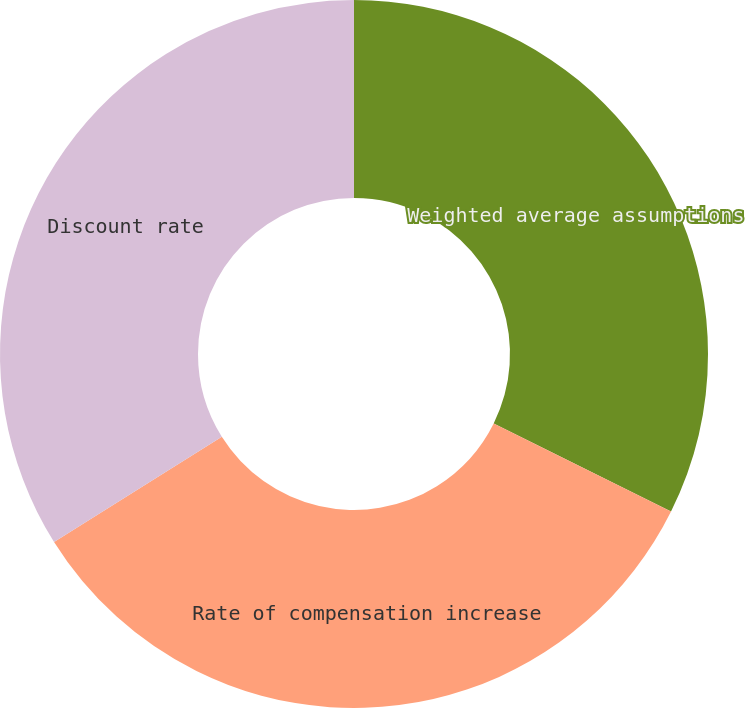Convert chart to OTSL. <chart><loc_0><loc_0><loc_500><loc_500><pie_chart><fcel>Weighted average assumptions<fcel>Rate of compensation increase<fcel>Discount rate<nl><fcel>32.34%<fcel>33.75%<fcel>33.91%<nl></chart> 